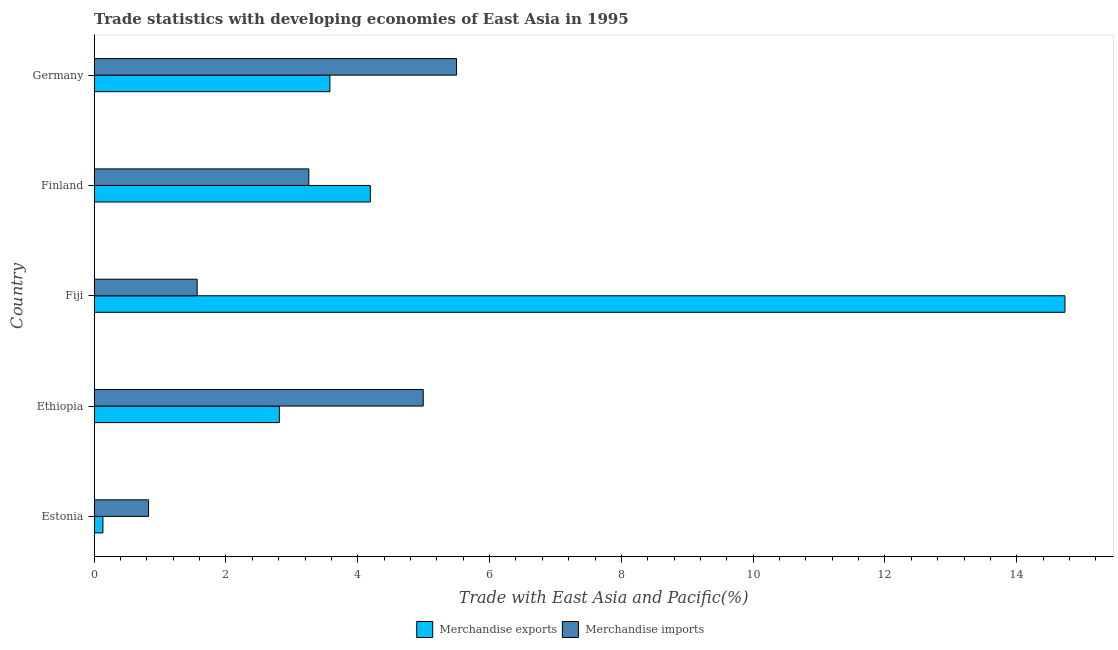How many different coloured bars are there?
Your answer should be very brief. 2. How many groups of bars are there?
Your answer should be very brief. 5. Are the number of bars per tick equal to the number of legend labels?
Your answer should be very brief. Yes. Are the number of bars on each tick of the Y-axis equal?
Make the answer very short. Yes. What is the label of the 1st group of bars from the top?
Provide a succinct answer. Germany. In how many cases, is the number of bars for a given country not equal to the number of legend labels?
Keep it short and to the point. 0. What is the merchandise imports in Finland?
Ensure brevity in your answer.  3.26. Across all countries, what is the maximum merchandise imports?
Keep it short and to the point. 5.5. Across all countries, what is the minimum merchandise exports?
Provide a short and direct response. 0.13. In which country was the merchandise exports maximum?
Give a very brief answer. Fiji. In which country was the merchandise imports minimum?
Make the answer very short. Estonia. What is the total merchandise exports in the graph?
Provide a succinct answer. 25.44. What is the difference between the merchandise exports in Ethiopia and that in Germany?
Keep it short and to the point. -0.77. What is the difference between the merchandise imports in Estonia and the merchandise exports in Ethiopia?
Your answer should be very brief. -1.99. What is the average merchandise imports per country?
Your response must be concise. 3.23. What is the difference between the merchandise exports and merchandise imports in Fiji?
Your answer should be compact. 13.17. In how many countries, is the merchandise exports greater than 1.6 %?
Offer a very short reply. 4. What is the ratio of the merchandise imports in Ethiopia to that in Fiji?
Offer a very short reply. 3.2. Is the merchandise imports in Estonia less than that in Finland?
Provide a short and direct response. Yes. Is the difference between the merchandise exports in Estonia and Germany greater than the difference between the merchandise imports in Estonia and Germany?
Offer a very short reply. Yes. What is the difference between the highest and the second highest merchandise exports?
Ensure brevity in your answer.  10.54. In how many countries, is the merchandise imports greater than the average merchandise imports taken over all countries?
Your answer should be very brief. 3. Is the sum of the merchandise imports in Finland and Germany greater than the maximum merchandise exports across all countries?
Ensure brevity in your answer.  No. What does the 1st bar from the top in Finland represents?
Offer a terse response. Merchandise imports. What does the 2nd bar from the bottom in Fiji represents?
Give a very brief answer. Merchandise imports. How many bars are there?
Offer a very short reply. 10. How many countries are there in the graph?
Provide a succinct answer. 5. Does the graph contain grids?
Offer a very short reply. No. Where does the legend appear in the graph?
Your response must be concise. Bottom center. How are the legend labels stacked?
Your answer should be compact. Horizontal. What is the title of the graph?
Provide a succinct answer. Trade statistics with developing economies of East Asia in 1995. What is the label or title of the X-axis?
Offer a very short reply. Trade with East Asia and Pacific(%). What is the Trade with East Asia and Pacific(%) in Merchandise exports in Estonia?
Ensure brevity in your answer.  0.13. What is the Trade with East Asia and Pacific(%) in Merchandise imports in Estonia?
Ensure brevity in your answer.  0.82. What is the Trade with East Asia and Pacific(%) in Merchandise exports in Ethiopia?
Provide a succinct answer. 2.81. What is the Trade with East Asia and Pacific(%) in Merchandise imports in Ethiopia?
Ensure brevity in your answer.  4.99. What is the Trade with East Asia and Pacific(%) of Merchandise exports in Fiji?
Provide a short and direct response. 14.73. What is the Trade with East Asia and Pacific(%) of Merchandise imports in Fiji?
Your answer should be very brief. 1.56. What is the Trade with East Asia and Pacific(%) in Merchandise exports in Finland?
Give a very brief answer. 4.19. What is the Trade with East Asia and Pacific(%) in Merchandise imports in Finland?
Offer a terse response. 3.26. What is the Trade with East Asia and Pacific(%) in Merchandise exports in Germany?
Keep it short and to the point. 3.58. What is the Trade with East Asia and Pacific(%) in Merchandise imports in Germany?
Give a very brief answer. 5.5. Across all countries, what is the maximum Trade with East Asia and Pacific(%) of Merchandise exports?
Provide a short and direct response. 14.73. Across all countries, what is the maximum Trade with East Asia and Pacific(%) of Merchandise imports?
Make the answer very short. 5.5. Across all countries, what is the minimum Trade with East Asia and Pacific(%) of Merchandise exports?
Your answer should be compact. 0.13. Across all countries, what is the minimum Trade with East Asia and Pacific(%) in Merchandise imports?
Provide a succinct answer. 0.82. What is the total Trade with East Asia and Pacific(%) in Merchandise exports in the graph?
Your answer should be very brief. 25.44. What is the total Trade with East Asia and Pacific(%) in Merchandise imports in the graph?
Give a very brief answer. 16.14. What is the difference between the Trade with East Asia and Pacific(%) of Merchandise exports in Estonia and that in Ethiopia?
Your answer should be compact. -2.68. What is the difference between the Trade with East Asia and Pacific(%) of Merchandise imports in Estonia and that in Ethiopia?
Your answer should be compact. -4.17. What is the difference between the Trade with East Asia and Pacific(%) in Merchandise exports in Estonia and that in Fiji?
Provide a short and direct response. -14.6. What is the difference between the Trade with East Asia and Pacific(%) of Merchandise imports in Estonia and that in Fiji?
Provide a short and direct response. -0.74. What is the difference between the Trade with East Asia and Pacific(%) in Merchandise exports in Estonia and that in Finland?
Offer a very short reply. -4.06. What is the difference between the Trade with East Asia and Pacific(%) of Merchandise imports in Estonia and that in Finland?
Your answer should be very brief. -2.43. What is the difference between the Trade with East Asia and Pacific(%) in Merchandise exports in Estonia and that in Germany?
Offer a terse response. -3.44. What is the difference between the Trade with East Asia and Pacific(%) in Merchandise imports in Estonia and that in Germany?
Provide a short and direct response. -4.67. What is the difference between the Trade with East Asia and Pacific(%) in Merchandise exports in Ethiopia and that in Fiji?
Provide a succinct answer. -11.92. What is the difference between the Trade with East Asia and Pacific(%) in Merchandise imports in Ethiopia and that in Fiji?
Offer a terse response. 3.43. What is the difference between the Trade with East Asia and Pacific(%) in Merchandise exports in Ethiopia and that in Finland?
Provide a short and direct response. -1.38. What is the difference between the Trade with East Asia and Pacific(%) of Merchandise imports in Ethiopia and that in Finland?
Offer a very short reply. 1.74. What is the difference between the Trade with East Asia and Pacific(%) of Merchandise exports in Ethiopia and that in Germany?
Give a very brief answer. -0.77. What is the difference between the Trade with East Asia and Pacific(%) of Merchandise imports in Ethiopia and that in Germany?
Ensure brevity in your answer.  -0.51. What is the difference between the Trade with East Asia and Pacific(%) in Merchandise exports in Fiji and that in Finland?
Provide a short and direct response. 10.54. What is the difference between the Trade with East Asia and Pacific(%) of Merchandise imports in Fiji and that in Finland?
Provide a succinct answer. -1.69. What is the difference between the Trade with East Asia and Pacific(%) in Merchandise exports in Fiji and that in Germany?
Offer a very short reply. 11.16. What is the difference between the Trade with East Asia and Pacific(%) of Merchandise imports in Fiji and that in Germany?
Your response must be concise. -3.94. What is the difference between the Trade with East Asia and Pacific(%) of Merchandise exports in Finland and that in Germany?
Make the answer very short. 0.61. What is the difference between the Trade with East Asia and Pacific(%) in Merchandise imports in Finland and that in Germany?
Your answer should be very brief. -2.24. What is the difference between the Trade with East Asia and Pacific(%) in Merchandise exports in Estonia and the Trade with East Asia and Pacific(%) in Merchandise imports in Ethiopia?
Your answer should be compact. -4.86. What is the difference between the Trade with East Asia and Pacific(%) in Merchandise exports in Estonia and the Trade with East Asia and Pacific(%) in Merchandise imports in Fiji?
Offer a very short reply. -1.43. What is the difference between the Trade with East Asia and Pacific(%) of Merchandise exports in Estonia and the Trade with East Asia and Pacific(%) of Merchandise imports in Finland?
Ensure brevity in your answer.  -3.12. What is the difference between the Trade with East Asia and Pacific(%) in Merchandise exports in Estonia and the Trade with East Asia and Pacific(%) in Merchandise imports in Germany?
Your answer should be compact. -5.37. What is the difference between the Trade with East Asia and Pacific(%) of Merchandise exports in Ethiopia and the Trade with East Asia and Pacific(%) of Merchandise imports in Fiji?
Keep it short and to the point. 1.25. What is the difference between the Trade with East Asia and Pacific(%) in Merchandise exports in Ethiopia and the Trade with East Asia and Pacific(%) in Merchandise imports in Finland?
Give a very brief answer. -0.45. What is the difference between the Trade with East Asia and Pacific(%) of Merchandise exports in Ethiopia and the Trade with East Asia and Pacific(%) of Merchandise imports in Germany?
Provide a short and direct response. -2.69. What is the difference between the Trade with East Asia and Pacific(%) of Merchandise exports in Fiji and the Trade with East Asia and Pacific(%) of Merchandise imports in Finland?
Give a very brief answer. 11.48. What is the difference between the Trade with East Asia and Pacific(%) of Merchandise exports in Fiji and the Trade with East Asia and Pacific(%) of Merchandise imports in Germany?
Make the answer very short. 9.23. What is the difference between the Trade with East Asia and Pacific(%) in Merchandise exports in Finland and the Trade with East Asia and Pacific(%) in Merchandise imports in Germany?
Your response must be concise. -1.31. What is the average Trade with East Asia and Pacific(%) in Merchandise exports per country?
Your answer should be compact. 5.09. What is the average Trade with East Asia and Pacific(%) in Merchandise imports per country?
Provide a succinct answer. 3.23. What is the difference between the Trade with East Asia and Pacific(%) of Merchandise exports and Trade with East Asia and Pacific(%) of Merchandise imports in Estonia?
Make the answer very short. -0.69. What is the difference between the Trade with East Asia and Pacific(%) of Merchandise exports and Trade with East Asia and Pacific(%) of Merchandise imports in Ethiopia?
Your answer should be very brief. -2.18. What is the difference between the Trade with East Asia and Pacific(%) in Merchandise exports and Trade with East Asia and Pacific(%) in Merchandise imports in Fiji?
Provide a short and direct response. 13.17. What is the difference between the Trade with East Asia and Pacific(%) of Merchandise exports and Trade with East Asia and Pacific(%) of Merchandise imports in Finland?
Offer a terse response. 0.93. What is the difference between the Trade with East Asia and Pacific(%) of Merchandise exports and Trade with East Asia and Pacific(%) of Merchandise imports in Germany?
Ensure brevity in your answer.  -1.92. What is the ratio of the Trade with East Asia and Pacific(%) of Merchandise exports in Estonia to that in Ethiopia?
Provide a succinct answer. 0.05. What is the ratio of the Trade with East Asia and Pacific(%) of Merchandise imports in Estonia to that in Ethiopia?
Your answer should be compact. 0.17. What is the ratio of the Trade with East Asia and Pacific(%) in Merchandise exports in Estonia to that in Fiji?
Give a very brief answer. 0.01. What is the ratio of the Trade with East Asia and Pacific(%) in Merchandise imports in Estonia to that in Fiji?
Offer a very short reply. 0.53. What is the ratio of the Trade with East Asia and Pacific(%) of Merchandise exports in Estonia to that in Finland?
Provide a short and direct response. 0.03. What is the ratio of the Trade with East Asia and Pacific(%) in Merchandise imports in Estonia to that in Finland?
Offer a terse response. 0.25. What is the ratio of the Trade with East Asia and Pacific(%) of Merchandise exports in Estonia to that in Germany?
Your answer should be compact. 0.04. What is the ratio of the Trade with East Asia and Pacific(%) of Merchandise imports in Estonia to that in Germany?
Provide a short and direct response. 0.15. What is the ratio of the Trade with East Asia and Pacific(%) in Merchandise exports in Ethiopia to that in Fiji?
Provide a succinct answer. 0.19. What is the ratio of the Trade with East Asia and Pacific(%) of Merchandise imports in Ethiopia to that in Fiji?
Make the answer very short. 3.2. What is the ratio of the Trade with East Asia and Pacific(%) in Merchandise exports in Ethiopia to that in Finland?
Keep it short and to the point. 0.67. What is the ratio of the Trade with East Asia and Pacific(%) in Merchandise imports in Ethiopia to that in Finland?
Your answer should be very brief. 1.53. What is the ratio of the Trade with East Asia and Pacific(%) of Merchandise exports in Ethiopia to that in Germany?
Provide a short and direct response. 0.79. What is the ratio of the Trade with East Asia and Pacific(%) of Merchandise imports in Ethiopia to that in Germany?
Give a very brief answer. 0.91. What is the ratio of the Trade with East Asia and Pacific(%) in Merchandise exports in Fiji to that in Finland?
Offer a very short reply. 3.52. What is the ratio of the Trade with East Asia and Pacific(%) in Merchandise imports in Fiji to that in Finland?
Provide a succinct answer. 0.48. What is the ratio of the Trade with East Asia and Pacific(%) of Merchandise exports in Fiji to that in Germany?
Provide a succinct answer. 4.12. What is the ratio of the Trade with East Asia and Pacific(%) in Merchandise imports in Fiji to that in Germany?
Offer a very short reply. 0.28. What is the ratio of the Trade with East Asia and Pacific(%) of Merchandise exports in Finland to that in Germany?
Provide a succinct answer. 1.17. What is the ratio of the Trade with East Asia and Pacific(%) in Merchandise imports in Finland to that in Germany?
Ensure brevity in your answer.  0.59. What is the difference between the highest and the second highest Trade with East Asia and Pacific(%) in Merchandise exports?
Keep it short and to the point. 10.54. What is the difference between the highest and the second highest Trade with East Asia and Pacific(%) in Merchandise imports?
Offer a terse response. 0.51. What is the difference between the highest and the lowest Trade with East Asia and Pacific(%) in Merchandise exports?
Make the answer very short. 14.6. What is the difference between the highest and the lowest Trade with East Asia and Pacific(%) of Merchandise imports?
Offer a very short reply. 4.67. 